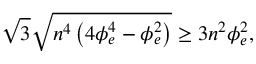<formula> <loc_0><loc_0><loc_500><loc_500>\sqrt { 3 } \sqrt { n ^ { 4 } \left ( 4 \phi _ { e } ^ { 4 } - \phi _ { e } ^ { 2 } \right ) } \geq 3 n ^ { 2 } \phi _ { e } ^ { 2 } ,</formula> 